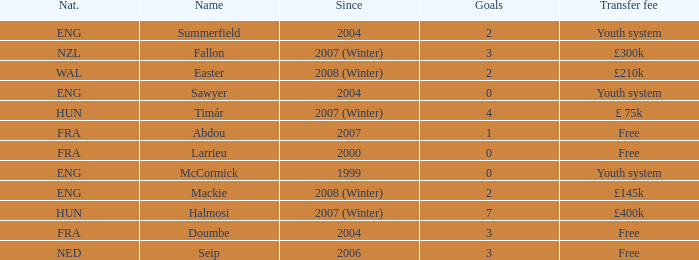What is the average goals Sawyer has? 0.0. 